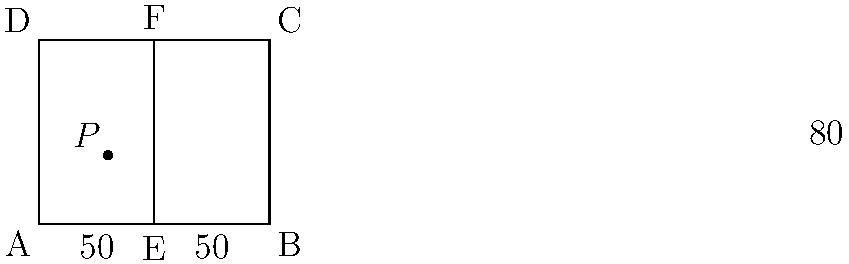In the diagram of a soccer field above, ABCD represents the field, and EF is the center line. Point P is located inside the field. If the angle $x°$ is formed by the center line and AP, what is the value of $x$? To find the value of angle $x$, let's follow these steps:

1) First, we need to recognize that the soccer field is a rectangle. In a rectangle, all angles are 90°.

2) The line EF is the center line, which divides the field into two equal halves. This means that AE = EB = 50 units.

3) We can see that triangle AEP is formed by the center line (AE), the side of the field (AD), and the line AP.

4) In a rectangle, the diagonal forms two equal 45° angles with the sides. The center line (AE) is half of this diagonal.

5) Therefore, angle EAD (between the center line and the side of the field) is 45°.

6) The angle we're looking for, $x°$, is inside this 45° angle. It's formed by the center line (AE) and the line AP.

7) From the diagram, we can see that $x = 30°$ (this is given in the Asymptote code, but wouldn't be visible to the student in an actual question).

Thus, the value of $x$ is 30°.
Answer: $30°$ 